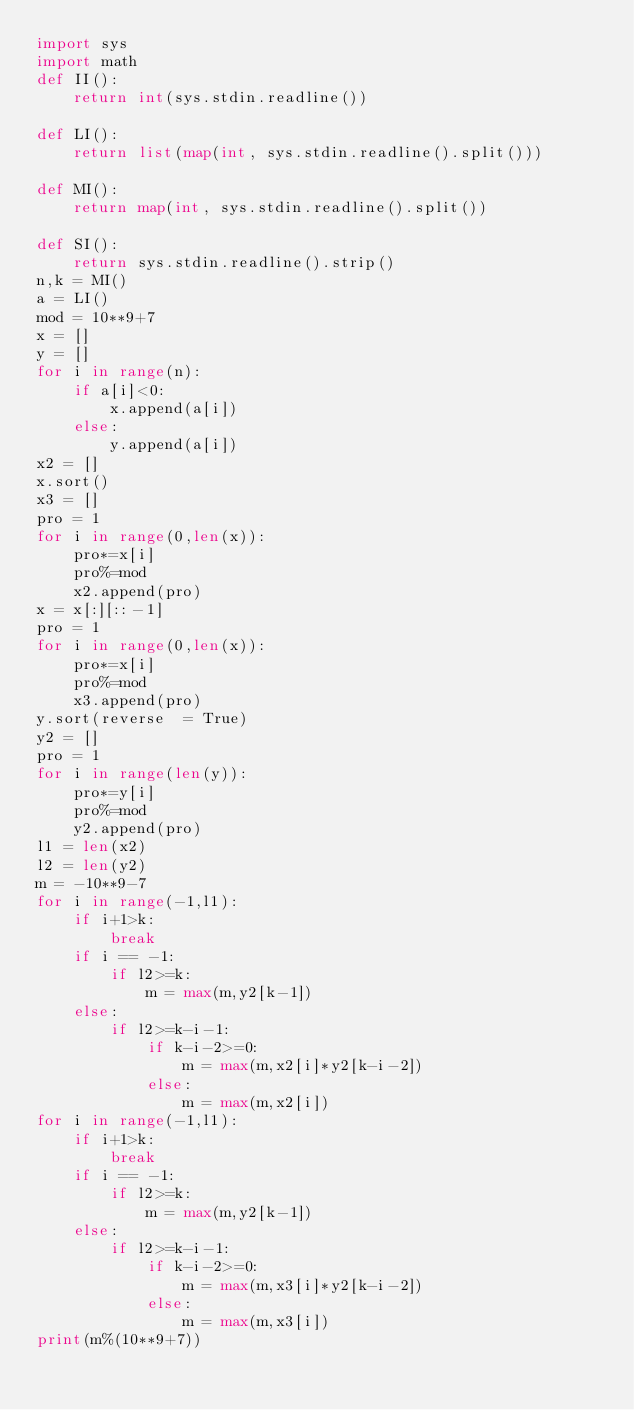<code> <loc_0><loc_0><loc_500><loc_500><_Python_>import sys
import math
def II():
	return int(sys.stdin.readline())

def LI():
	return list(map(int, sys.stdin.readline().split()))

def MI():
	return map(int, sys.stdin.readline().split())

def SI():
	return sys.stdin.readline().strip()
n,k = MI()
a = LI()
mod = 10**9+7
x = []
y = []
for i in range(n):
	if a[i]<0:
		x.append(a[i])
	else:
		y.append(a[i])
x2 = []
x.sort()
x3 = []
pro = 1
for i in range(0,len(x)):
	pro*=x[i]
	pro%=mod
	x2.append(pro)
x = x[:][::-1]
pro = 1
for i in range(0,len(x)):
	pro*=x[i]
	pro%=mod
	x3.append(pro)
y.sort(reverse  = True)
y2 = []
pro = 1
for i in range(len(y)):
	pro*=y[i]
	pro%=mod
	y2.append(pro)
l1 = len(x2)
l2 = len(y2)
m = -10**9-7
for i in range(-1,l1):
	if i+1>k:
		break
	if i == -1:
		if l2>=k:
			m = max(m,y2[k-1])
	else:
		if l2>=k-i-1:
			if k-i-2>=0:
				m = max(m,x2[i]*y2[k-i-2])
			else:
				m = max(m,x2[i])
for i in range(-1,l1):
	if i+1>k:
		break
	if i == -1:
		if l2>=k:
			m = max(m,y2[k-1])
	else:
		if l2>=k-i-1:
			if k-i-2>=0:
				m = max(m,x3[i]*y2[k-i-2])
			else:
				m = max(m,x3[i])
print(m%(10**9+7))

</code> 